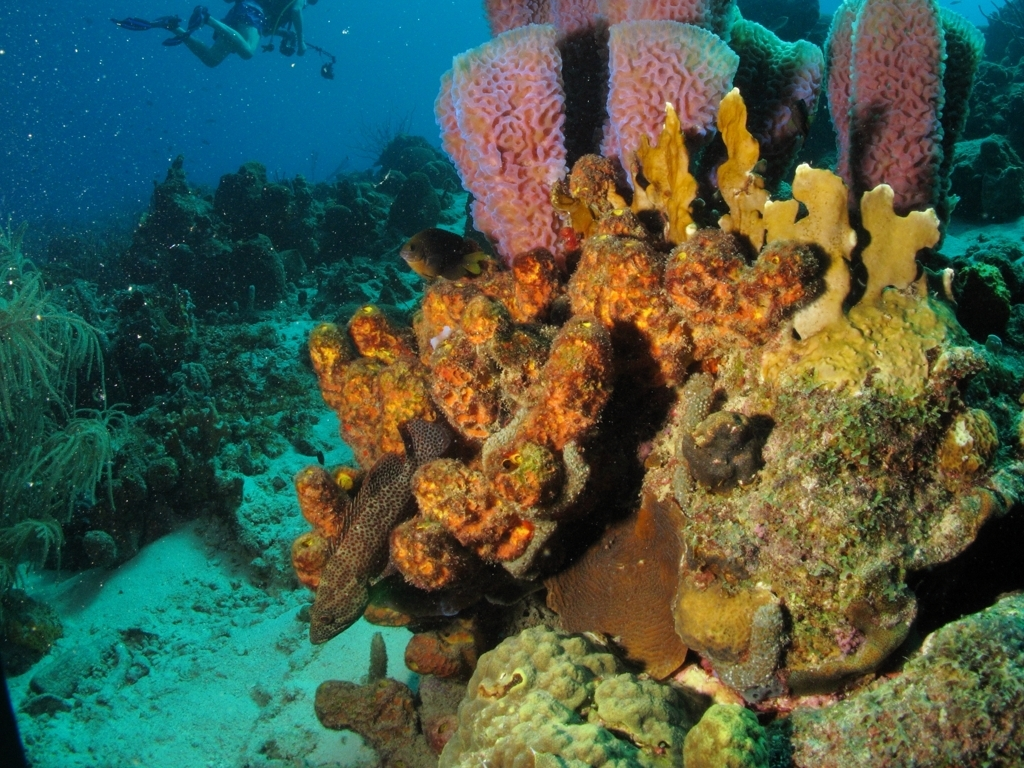Are the colors in the image rich and vivid? Yes, the colors in the image are indeed rich and vivid. The underwater scene is a collage of vibrant colors, with various shades of pink, yellow, and orange seen in the coral formations, creating a striking visual that is aesthetically pleasing and full of life. 